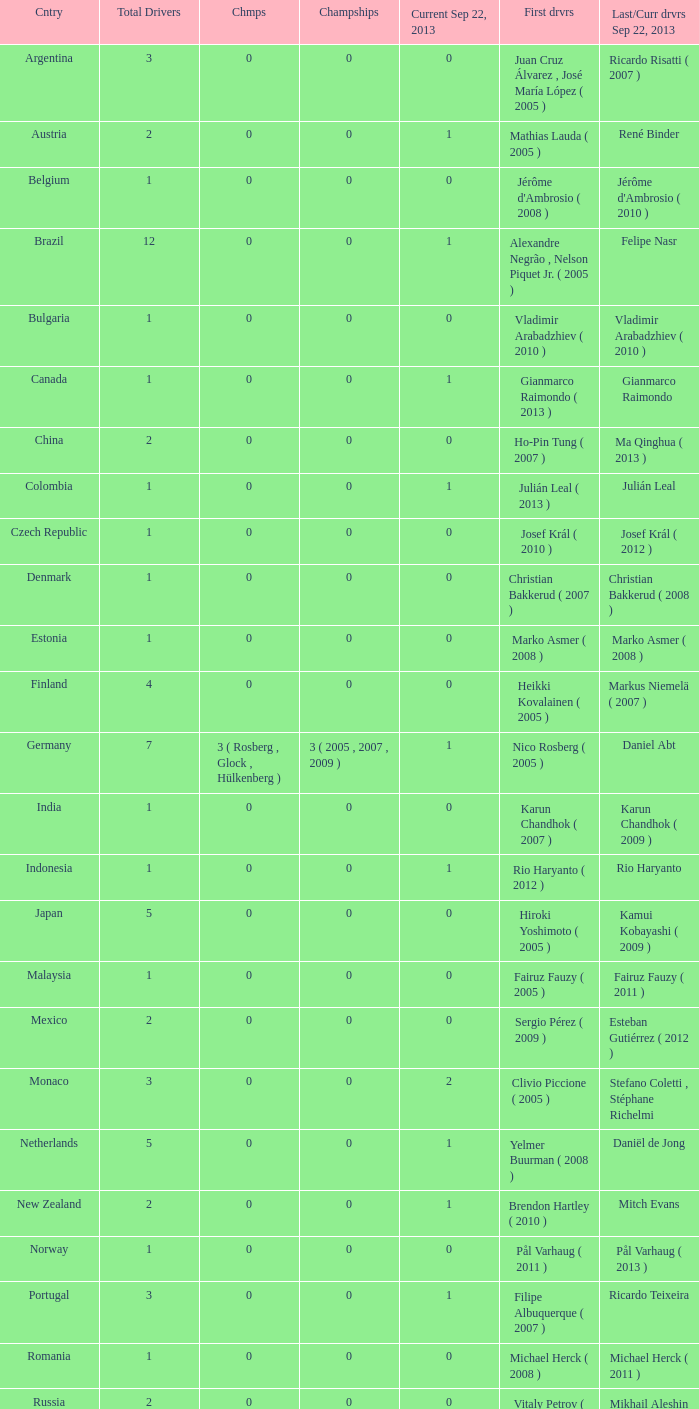How many champions were there when the first driver was hiroki yoshimoto ( 2005 )? 0.0. 